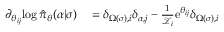<formula> <loc_0><loc_0><loc_500><loc_500>\begin{array} { r l } { \partial _ { \theta _ { i j } } \, \log \hat { \pi } _ { \theta } ( \alpha | \sigma ) } & = \delta _ { \Omega ( \sigma ) , i } \delta _ { \alpha , j } - \frac { 1 } { \mathcal { Z } _ { i } } e ^ { \theta _ { i j } } \delta _ { \Omega ( \sigma ) , i } } \end{array}</formula> 